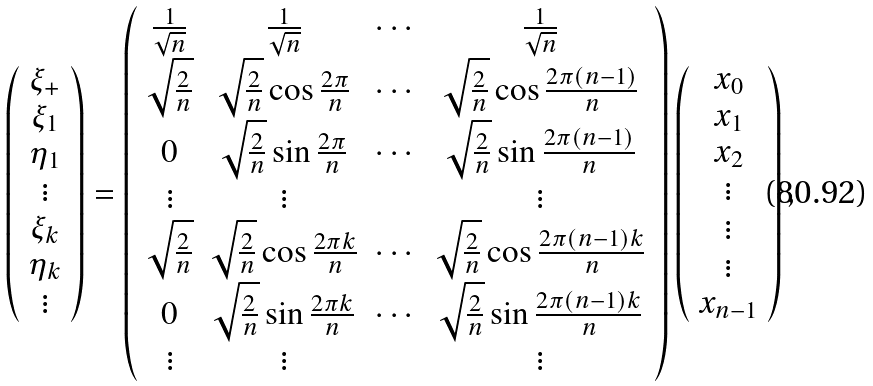Convert formula to latex. <formula><loc_0><loc_0><loc_500><loc_500>\left ( \begin{array} { c } \xi _ { + } \\ \xi _ { 1 } \\ \eta _ { 1 } \\ \vdots \\ \xi _ { k } \\ \eta _ { k } \\ \vdots \end{array} \right ) = \left ( \begin{array} { c c c c } \frac { 1 } { \sqrt { n } } & \frac { 1 } { \sqrt { n } } & \cdots & \frac { 1 } { \sqrt { n } } \\ \sqrt { \frac { 2 } { n } } & \sqrt { \frac { 2 } { n } } \cos \frac { 2 \pi } { n } & \cdots & \sqrt { \frac { 2 } { n } } \cos \frac { 2 \pi ( n - 1 ) } { n } \\ 0 & \sqrt { \frac { 2 } { n } } \sin \frac { 2 \pi } { n } & \cdots & \sqrt { \frac { 2 } { n } } \sin \frac { 2 \pi ( n - 1 ) } { n } \\ \vdots & \vdots & & \vdots \\ \sqrt { \frac { 2 } { n } } & \sqrt { \frac { 2 } { n } } \cos \frac { 2 \pi k } { n } & \cdots & \sqrt { \frac { 2 } { n } } \cos \frac { 2 \pi ( n - 1 ) k } { n } \\ 0 & \sqrt { \frac { 2 } { n } } \sin \frac { 2 \pi k } { n } & \cdots & \sqrt { \frac { 2 } { n } } \sin \frac { 2 \pi ( n - 1 ) k } { n } \\ \vdots & \vdots & & \vdots \end{array} \right ) \left ( \begin{array} { c } x _ { 0 } \\ x _ { 1 } \\ x _ { 2 } \\ \vdots \\ \vdots \\ \vdots \\ x _ { n - 1 } \end{array} \right ) ,</formula> 